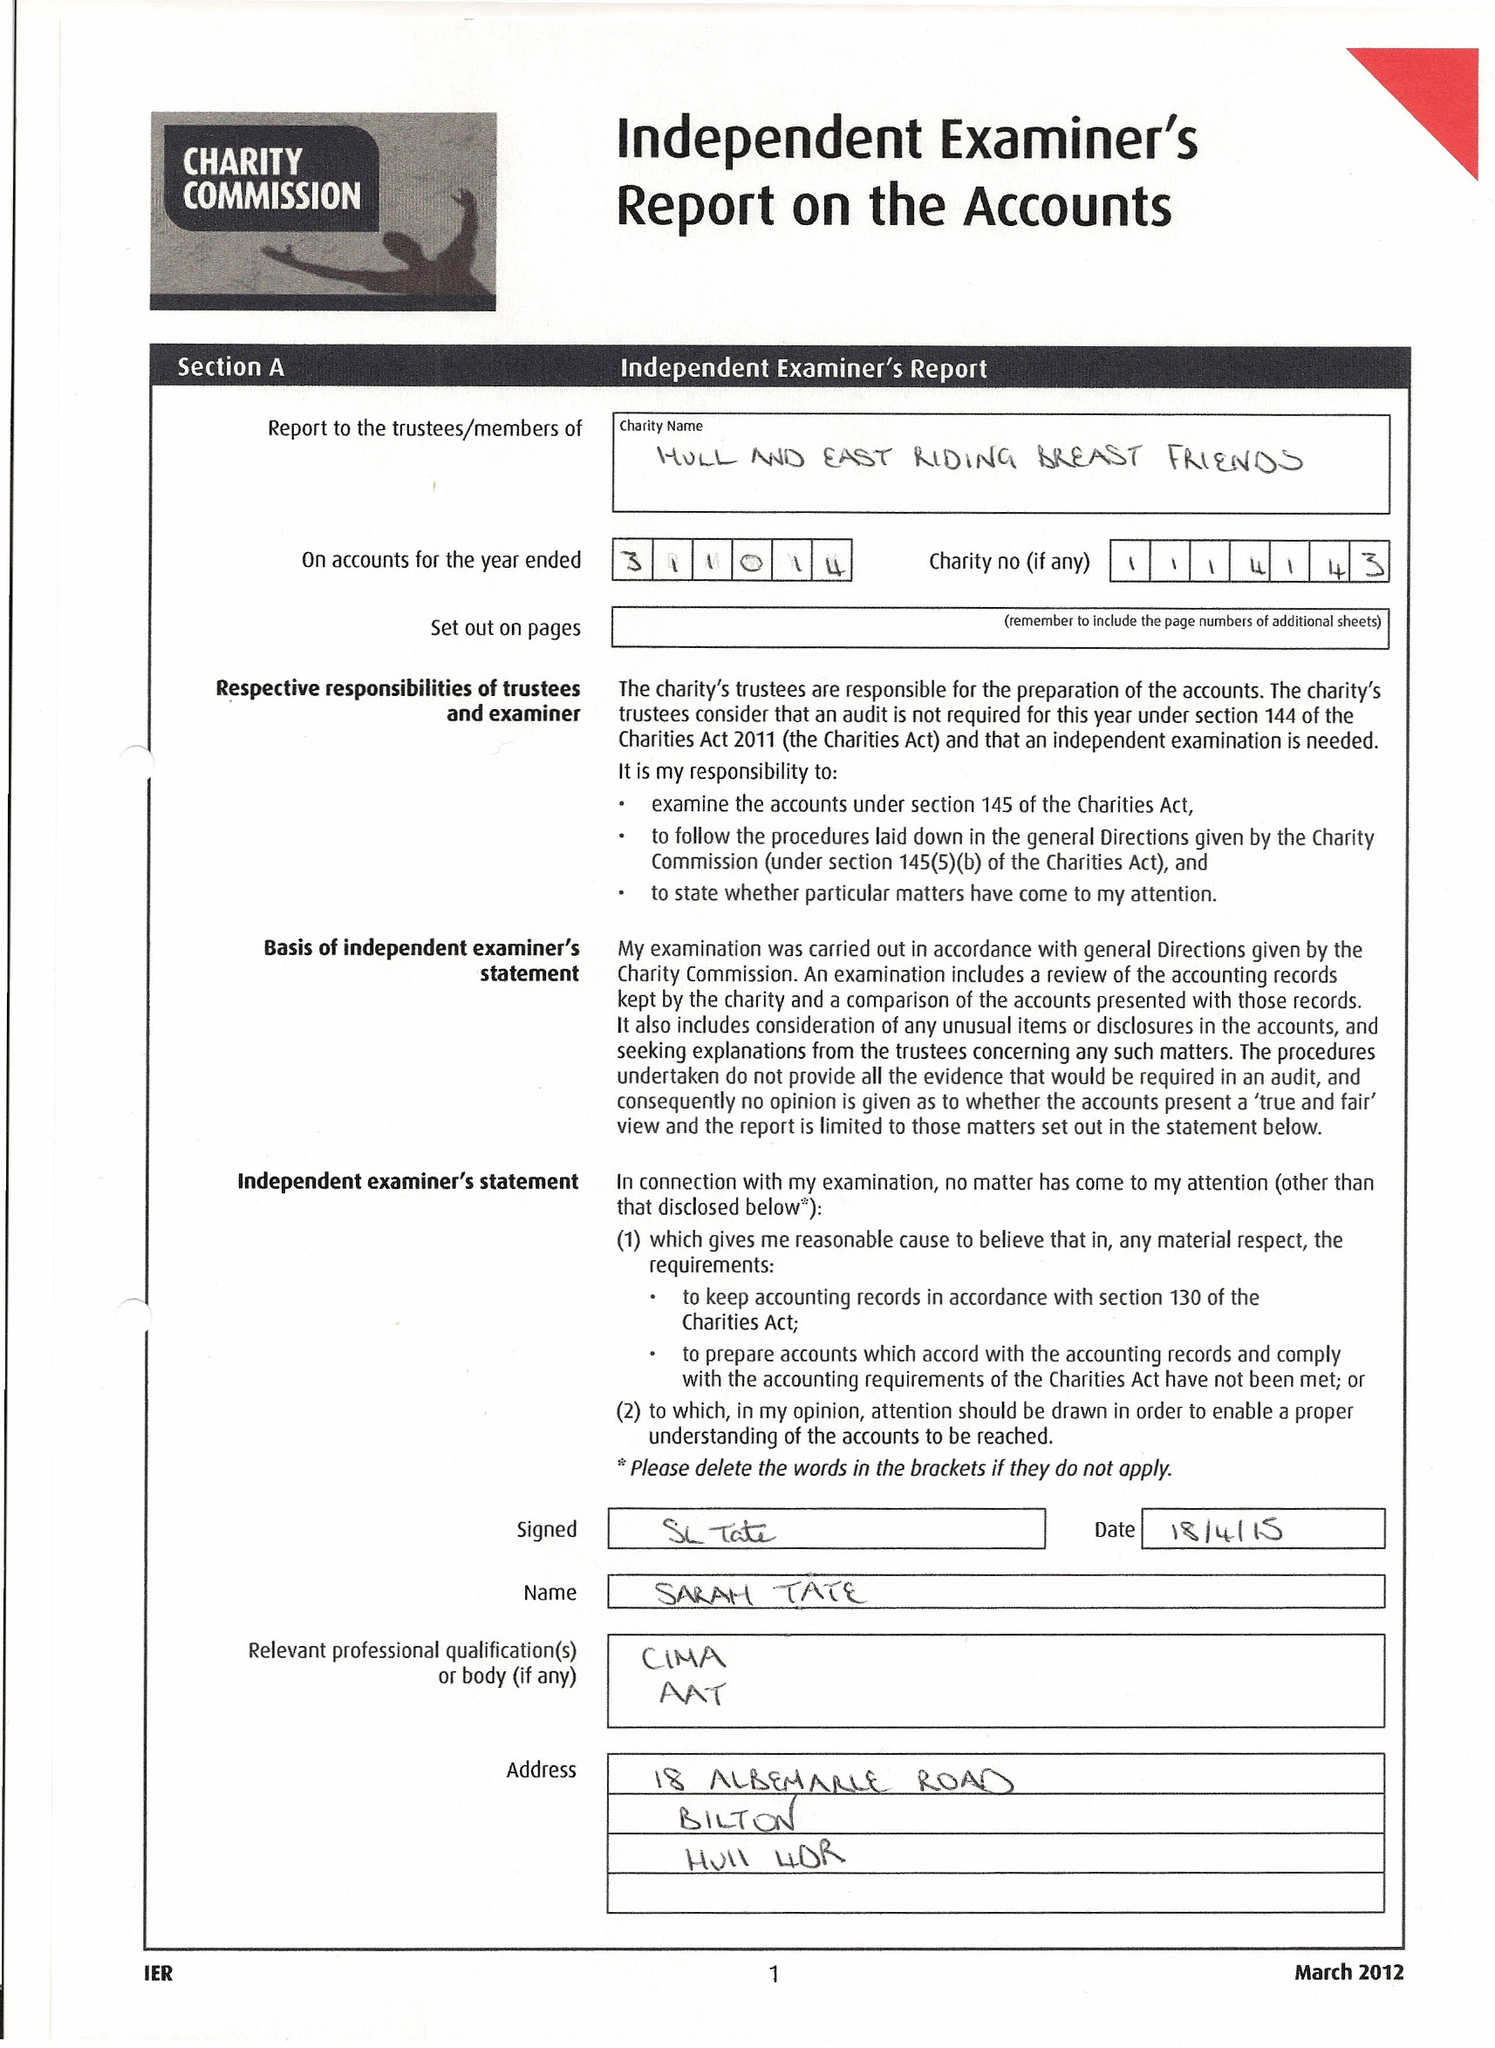What is the value for the report_date?
Answer the question using a single word or phrase. 2014-10-31 